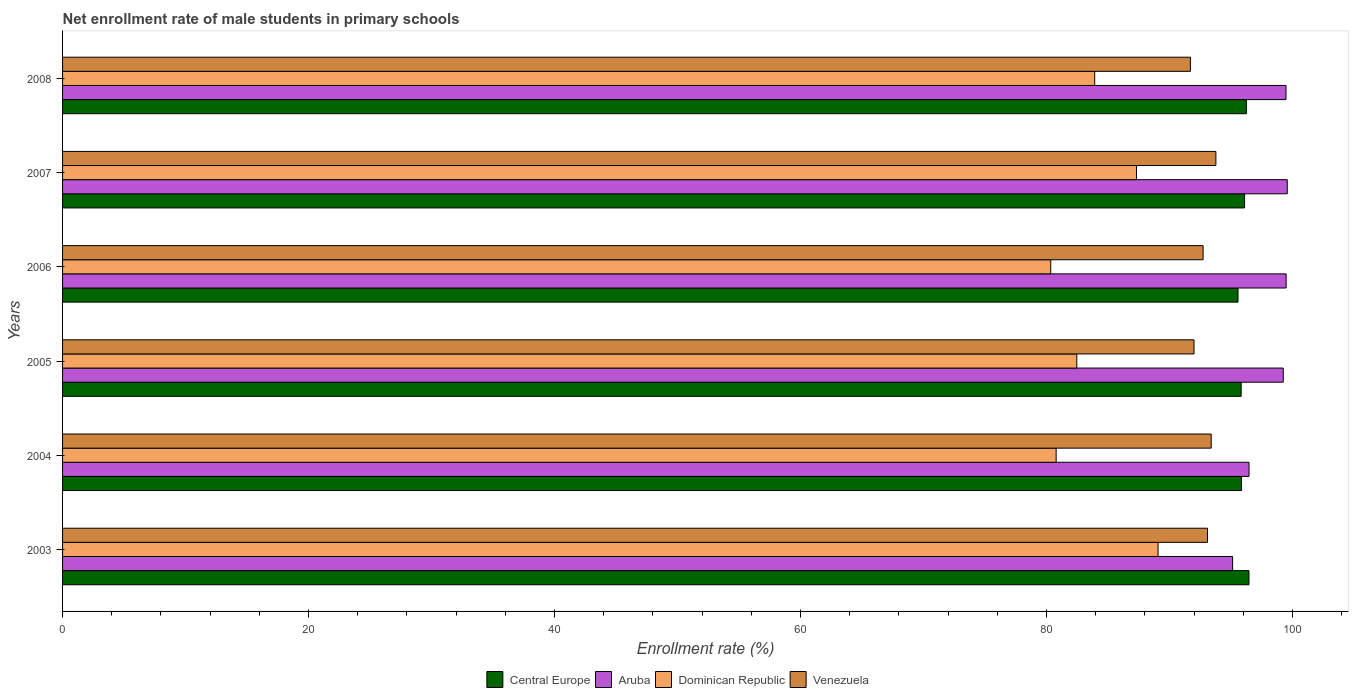How many groups of bars are there?
Your response must be concise. 6. How many bars are there on the 2nd tick from the bottom?
Keep it short and to the point. 4. What is the label of the 1st group of bars from the top?
Ensure brevity in your answer.  2008. What is the net enrollment rate of male students in primary schools in Dominican Republic in 2008?
Give a very brief answer. 83.91. Across all years, what is the maximum net enrollment rate of male students in primary schools in Venezuela?
Make the answer very short. 93.76. Across all years, what is the minimum net enrollment rate of male students in primary schools in Central Europe?
Offer a very short reply. 95.56. In which year was the net enrollment rate of male students in primary schools in Aruba maximum?
Your answer should be very brief. 2007. What is the total net enrollment rate of male students in primary schools in Dominican Republic in the graph?
Make the answer very short. 503.86. What is the difference between the net enrollment rate of male students in primary schools in Central Europe in 2004 and that in 2007?
Your answer should be very brief. -0.25. What is the difference between the net enrollment rate of male students in primary schools in Aruba in 2007 and the net enrollment rate of male students in primary schools in Venezuela in 2003?
Give a very brief answer. 6.48. What is the average net enrollment rate of male students in primary schools in Aruba per year?
Ensure brevity in your answer.  98.22. In the year 2004, what is the difference between the net enrollment rate of male students in primary schools in Central Europe and net enrollment rate of male students in primary schools in Venezuela?
Your answer should be very brief. 2.46. What is the ratio of the net enrollment rate of male students in primary schools in Venezuela in 2004 to that in 2007?
Keep it short and to the point. 1. Is the net enrollment rate of male students in primary schools in Venezuela in 2003 less than that in 2007?
Make the answer very short. Yes. What is the difference between the highest and the second highest net enrollment rate of male students in primary schools in Dominican Republic?
Provide a succinct answer. 1.75. What is the difference between the highest and the lowest net enrollment rate of male students in primary schools in Dominican Republic?
Offer a very short reply. 8.73. In how many years, is the net enrollment rate of male students in primary schools in Aruba greater than the average net enrollment rate of male students in primary schools in Aruba taken over all years?
Your answer should be compact. 4. Is the sum of the net enrollment rate of male students in primary schools in Aruba in 2006 and 2007 greater than the maximum net enrollment rate of male students in primary schools in Central Europe across all years?
Your answer should be compact. Yes. Is it the case that in every year, the sum of the net enrollment rate of male students in primary schools in Central Europe and net enrollment rate of male students in primary schools in Venezuela is greater than the sum of net enrollment rate of male students in primary schools in Dominican Republic and net enrollment rate of male students in primary schools in Aruba?
Your response must be concise. Yes. What does the 4th bar from the top in 2007 represents?
Make the answer very short. Central Europe. What does the 4th bar from the bottom in 2006 represents?
Provide a succinct answer. Venezuela. How many years are there in the graph?
Provide a succinct answer. 6. What is the difference between two consecutive major ticks on the X-axis?
Ensure brevity in your answer.  20. Are the values on the major ticks of X-axis written in scientific E-notation?
Your answer should be compact. No. Does the graph contain any zero values?
Provide a short and direct response. No. Does the graph contain grids?
Offer a very short reply. No. How many legend labels are there?
Your response must be concise. 4. What is the title of the graph?
Your answer should be very brief. Net enrollment rate of male students in primary schools. What is the label or title of the X-axis?
Provide a succinct answer. Enrollment rate (%). What is the Enrollment rate (%) in Central Europe in 2003?
Provide a succinct answer. 96.46. What is the Enrollment rate (%) of Aruba in 2003?
Provide a succinct answer. 95.13. What is the Enrollment rate (%) in Dominican Republic in 2003?
Provide a succinct answer. 89.06. What is the Enrollment rate (%) of Venezuela in 2003?
Make the answer very short. 93.08. What is the Enrollment rate (%) of Central Europe in 2004?
Provide a short and direct response. 95.85. What is the Enrollment rate (%) of Aruba in 2004?
Offer a very short reply. 96.46. What is the Enrollment rate (%) of Dominican Republic in 2004?
Give a very brief answer. 80.78. What is the Enrollment rate (%) in Venezuela in 2004?
Give a very brief answer. 93.38. What is the Enrollment rate (%) in Central Europe in 2005?
Provide a short and direct response. 95.82. What is the Enrollment rate (%) in Aruba in 2005?
Offer a very short reply. 99.24. What is the Enrollment rate (%) in Dominican Republic in 2005?
Offer a very short reply. 82.46. What is the Enrollment rate (%) in Venezuela in 2005?
Offer a very short reply. 91.99. What is the Enrollment rate (%) in Central Europe in 2006?
Your answer should be very brief. 95.56. What is the Enrollment rate (%) in Aruba in 2006?
Your answer should be very brief. 99.48. What is the Enrollment rate (%) in Dominican Republic in 2006?
Your response must be concise. 80.34. What is the Enrollment rate (%) of Venezuela in 2006?
Your answer should be very brief. 92.72. What is the Enrollment rate (%) in Central Europe in 2007?
Keep it short and to the point. 96.1. What is the Enrollment rate (%) of Aruba in 2007?
Give a very brief answer. 99.57. What is the Enrollment rate (%) in Dominican Republic in 2007?
Make the answer very short. 87.31. What is the Enrollment rate (%) of Venezuela in 2007?
Give a very brief answer. 93.76. What is the Enrollment rate (%) of Central Europe in 2008?
Ensure brevity in your answer.  96.24. What is the Enrollment rate (%) of Aruba in 2008?
Your response must be concise. 99.46. What is the Enrollment rate (%) in Dominican Republic in 2008?
Provide a short and direct response. 83.91. What is the Enrollment rate (%) in Venezuela in 2008?
Ensure brevity in your answer.  91.69. Across all years, what is the maximum Enrollment rate (%) of Central Europe?
Provide a short and direct response. 96.46. Across all years, what is the maximum Enrollment rate (%) in Aruba?
Your response must be concise. 99.57. Across all years, what is the maximum Enrollment rate (%) in Dominican Republic?
Your response must be concise. 89.06. Across all years, what is the maximum Enrollment rate (%) in Venezuela?
Keep it short and to the point. 93.76. Across all years, what is the minimum Enrollment rate (%) of Central Europe?
Provide a succinct answer. 95.56. Across all years, what is the minimum Enrollment rate (%) of Aruba?
Provide a succinct answer. 95.13. Across all years, what is the minimum Enrollment rate (%) of Dominican Republic?
Offer a very short reply. 80.34. Across all years, what is the minimum Enrollment rate (%) of Venezuela?
Your answer should be compact. 91.69. What is the total Enrollment rate (%) of Central Europe in the graph?
Ensure brevity in your answer.  576.03. What is the total Enrollment rate (%) in Aruba in the graph?
Give a very brief answer. 589.34. What is the total Enrollment rate (%) in Dominican Republic in the graph?
Provide a short and direct response. 503.86. What is the total Enrollment rate (%) of Venezuela in the graph?
Your answer should be compact. 556.64. What is the difference between the Enrollment rate (%) in Central Europe in 2003 and that in 2004?
Your answer should be very brief. 0.61. What is the difference between the Enrollment rate (%) in Aruba in 2003 and that in 2004?
Offer a very short reply. -1.34. What is the difference between the Enrollment rate (%) in Dominican Republic in 2003 and that in 2004?
Provide a succinct answer. 8.29. What is the difference between the Enrollment rate (%) in Venezuela in 2003 and that in 2004?
Ensure brevity in your answer.  -0.3. What is the difference between the Enrollment rate (%) of Central Europe in 2003 and that in 2005?
Keep it short and to the point. 0.63. What is the difference between the Enrollment rate (%) of Aruba in 2003 and that in 2005?
Keep it short and to the point. -4.12. What is the difference between the Enrollment rate (%) in Dominican Republic in 2003 and that in 2005?
Offer a terse response. 6.61. What is the difference between the Enrollment rate (%) of Venezuela in 2003 and that in 2005?
Your answer should be very brief. 1.1. What is the difference between the Enrollment rate (%) of Central Europe in 2003 and that in 2006?
Provide a short and direct response. 0.89. What is the difference between the Enrollment rate (%) of Aruba in 2003 and that in 2006?
Your answer should be compact. -4.35. What is the difference between the Enrollment rate (%) of Dominican Republic in 2003 and that in 2006?
Keep it short and to the point. 8.73. What is the difference between the Enrollment rate (%) of Venezuela in 2003 and that in 2006?
Keep it short and to the point. 0.36. What is the difference between the Enrollment rate (%) of Central Europe in 2003 and that in 2007?
Your answer should be compact. 0.36. What is the difference between the Enrollment rate (%) of Aruba in 2003 and that in 2007?
Your response must be concise. -4.44. What is the difference between the Enrollment rate (%) in Dominican Republic in 2003 and that in 2007?
Your answer should be very brief. 1.75. What is the difference between the Enrollment rate (%) in Venezuela in 2003 and that in 2007?
Offer a terse response. -0.68. What is the difference between the Enrollment rate (%) of Central Europe in 2003 and that in 2008?
Make the answer very short. 0.21. What is the difference between the Enrollment rate (%) of Aruba in 2003 and that in 2008?
Keep it short and to the point. -4.34. What is the difference between the Enrollment rate (%) in Dominican Republic in 2003 and that in 2008?
Keep it short and to the point. 5.15. What is the difference between the Enrollment rate (%) of Venezuela in 2003 and that in 2008?
Offer a terse response. 1.39. What is the difference between the Enrollment rate (%) of Central Europe in 2004 and that in 2005?
Give a very brief answer. 0.02. What is the difference between the Enrollment rate (%) in Aruba in 2004 and that in 2005?
Provide a succinct answer. -2.78. What is the difference between the Enrollment rate (%) in Dominican Republic in 2004 and that in 2005?
Make the answer very short. -1.68. What is the difference between the Enrollment rate (%) of Venezuela in 2004 and that in 2005?
Your answer should be compact. 1.4. What is the difference between the Enrollment rate (%) in Central Europe in 2004 and that in 2006?
Offer a terse response. 0.28. What is the difference between the Enrollment rate (%) of Aruba in 2004 and that in 2006?
Make the answer very short. -3.02. What is the difference between the Enrollment rate (%) in Dominican Republic in 2004 and that in 2006?
Make the answer very short. 0.44. What is the difference between the Enrollment rate (%) in Venezuela in 2004 and that in 2006?
Provide a short and direct response. 0.66. What is the difference between the Enrollment rate (%) of Central Europe in 2004 and that in 2007?
Your response must be concise. -0.25. What is the difference between the Enrollment rate (%) in Aruba in 2004 and that in 2007?
Your answer should be compact. -3.11. What is the difference between the Enrollment rate (%) of Dominican Republic in 2004 and that in 2007?
Make the answer very short. -6.53. What is the difference between the Enrollment rate (%) in Venezuela in 2004 and that in 2007?
Keep it short and to the point. -0.38. What is the difference between the Enrollment rate (%) in Central Europe in 2004 and that in 2008?
Provide a succinct answer. -0.4. What is the difference between the Enrollment rate (%) of Aruba in 2004 and that in 2008?
Give a very brief answer. -3. What is the difference between the Enrollment rate (%) in Dominican Republic in 2004 and that in 2008?
Make the answer very short. -3.13. What is the difference between the Enrollment rate (%) in Venezuela in 2004 and that in 2008?
Your answer should be compact. 1.69. What is the difference between the Enrollment rate (%) of Central Europe in 2005 and that in 2006?
Provide a short and direct response. 0.26. What is the difference between the Enrollment rate (%) in Aruba in 2005 and that in 2006?
Give a very brief answer. -0.24. What is the difference between the Enrollment rate (%) in Dominican Republic in 2005 and that in 2006?
Ensure brevity in your answer.  2.12. What is the difference between the Enrollment rate (%) of Venezuela in 2005 and that in 2006?
Make the answer very short. -0.74. What is the difference between the Enrollment rate (%) in Central Europe in 2005 and that in 2007?
Provide a short and direct response. -0.28. What is the difference between the Enrollment rate (%) in Aruba in 2005 and that in 2007?
Your response must be concise. -0.33. What is the difference between the Enrollment rate (%) in Dominican Republic in 2005 and that in 2007?
Give a very brief answer. -4.86. What is the difference between the Enrollment rate (%) in Venezuela in 2005 and that in 2007?
Make the answer very short. -1.78. What is the difference between the Enrollment rate (%) of Central Europe in 2005 and that in 2008?
Offer a very short reply. -0.42. What is the difference between the Enrollment rate (%) of Aruba in 2005 and that in 2008?
Make the answer very short. -0.22. What is the difference between the Enrollment rate (%) of Dominican Republic in 2005 and that in 2008?
Your response must be concise. -1.46. What is the difference between the Enrollment rate (%) of Venezuela in 2005 and that in 2008?
Your response must be concise. 0.29. What is the difference between the Enrollment rate (%) in Central Europe in 2006 and that in 2007?
Provide a succinct answer. -0.53. What is the difference between the Enrollment rate (%) in Aruba in 2006 and that in 2007?
Give a very brief answer. -0.09. What is the difference between the Enrollment rate (%) in Dominican Republic in 2006 and that in 2007?
Ensure brevity in your answer.  -6.97. What is the difference between the Enrollment rate (%) in Venezuela in 2006 and that in 2007?
Provide a succinct answer. -1.04. What is the difference between the Enrollment rate (%) of Central Europe in 2006 and that in 2008?
Your response must be concise. -0.68. What is the difference between the Enrollment rate (%) in Aruba in 2006 and that in 2008?
Make the answer very short. 0.01. What is the difference between the Enrollment rate (%) of Dominican Republic in 2006 and that in 2008?
Make the answer very short. -3.57. What is the difference between the Enrollment rate (%) of Venezuela in 2006 and that in 2008?
Provide a short and direct response. 1.03. What is the difference between the Enrollment rate (%) of Central Europe in 2007 and that in 2008?
Your answer should be compact. -0.14. What is the difference between the Enrollment rate (%) in Aruba in 2007 and that in 2008?
Provide a short and direct response. 0.1. What is the difference between the Enrollment rate (%) of Dominican Republic in 2007 and that in 2008?
Ensure brevity in your answer.  3.4. What is the difference between the Enrollment rate (%) in Venezuela in 2007 and that in 2008?
Offer a very short reply. 2.07. What is the difference between the Enrollment rate (%) of Central Europe in 2003 and the Enrollment rate (%) of Aruba in 2004?
Provide a short and direct response. -0. What is the difference between the Enrollment rate (%) of Central Europe in 2003 and the Enrollment rate (%) of Dominican Republic in 2004?
Provide a succinct answer. 15.68. What is the difference between the Enrollment rate (%) in Central Europe in 2003 and the Enrollment rate (%) in Venezuela in 2004?
Provide a short and direct response. 3.07. What is the difference between the Enrollment rate (%) of Aruba in 2003 and the Enrollment rate (%) of Dominican Republic in 2004?
Ensure brevity in your answer.  14.35. What is the difference between the Enrollment rate (%) in Aruba in 2003 and the Enrollment rate (%) in Venezuela in 2004?
Provide a succinct answer. 1.74. What is the difference between the Enrollment rate (%) of Dominican Republic in 2003 and the Enrollment rate (%) of Venezuela in 2004?
Make the answer very short. -4.32. What is the difference between the Enrollment rate (%) in Central Europe in 2003 and the Enrollment rate (%) in Aruba in 2005?
Keep it short and to the point. -2.78. What is the difference between the Enrollment rate (%) of Central Europe in 2003 and the Enrollment rate (%) of Dominican Republic in 2005?
Your answer should be very brief. 14. What is the difference between the Enrollment rate (%) in Central Europe in 2003 and the Enrollment rate (%) in Venezuela in 2005?
Provide a succinct answer. 4.47. What is the difference between the Enrollment rate (%) in Aruba in 2003 and the Enrollment rate (%) in Dominican Republic in 2005?
Provide a succinct answer. 12.67. What is the difference between the Enrollment rate (%) of Aruba in 2003 and the Enrollment rate (%) of Venezuela in 2005?
Give a very brief answer. 3.14. What is the difference between the Enrollment rate (%) of Dominican Republic in 2003 and the Enrollment rate (%) of Venezuela in 2005?
Offer a terse response. -2.92. What is the difference between the Enrollment rate (%) in Central Europe in 2003 and the Enrollment rate (%) in Aruba in 2006?
Your answer should be compact. -3.02. What is the difference between the Enrollment rate (%) of Central Europe in 2003 and the Enrollment rate (%) of Dominican Republic in 2006?
Your answer should be compact. 16.12. What is the difference between the Enrollment rate (%) in Central Europe in 2003 and the Enrollment rate (%) in Venezuela in 2006?
Provide a short and direct response. 3.73. What is the difference between the Enrollment rate (%) in Aruba in 2003 and the Enrollment rate (%) in Dominican Republic in 2006?
Make the answer very short. 14.79. What is the difference between the Enrollment rate (%) of Aruba in 2003 and the Enrollment rate (%) of Venezuela in 2006?
Ensure brevity in your answer.  2.4. What is the difference between the Enrollment rate (%) of Dominican Republic in 2003 and the Enrollment rate (%) of Venezuela in 2006?
Give a very brief answer. -3.66. What is the difference between the Enrollment rate (%) of Central Europe in 2003 and the Enrollment rate (%) of Aruba in 2007?
Offer a very short reply. -3.11. What is the difference between the Enrollment rate (%) in Central Europe in 2003 and the Enrollment rate (%) in Dominican Republic in 2007?
Provide a succinct answer. 9.14. What is the difference between the Enrollment rate (%) of Central Europe in 2003 and the Enrollment rate (%) of Venezuela in 2007?
Give a very brief answer. 2.69. What is the difference between the Enrollment rate (%) in Aruba in 2003 and the Enrollment rate (%) in Dominican Republic in 2007?
Give a very brief answer. 7.81. What is the difference between the Enrollment rate (%) in Aruba in 2003 and the Enrollment rate (%) in Venezuela in 2007?
Your answer should be compact. 1.36. What is the difference between the Enrollment rate (%) of Dominican Republic in 2003 and the Enrollment rate (%) of Venezuela in 2007?
Provide a short and direct response. -4.7. What is the difference between the Enrollment rate (%) in Central Europe in 2003 and the Enrollment rate (%) in Aruba in 2008?
Provide a succinct answer. -3.01. What is the difference between the Enrollment rate (%) in Central Europe in 2003 and the Enrollment rate (%) in Dominican Republic in 2008?
Provide a short and direct response. 12.54. What is the difference between the Enrollment rate (%) of Central Europe in 2003 and the Enrollment rate (%) of Venezuela in 2008?
Make the answer very short. 4.76. What is the difference between the Enrollment rate (%) in Aruba in 2003 and the Enrollment rate (%) in Dominican Republic in 2008?
Provide a short and direct response. 11.21. What is the difference between the Enrollment rate (%) in Aruba in 2003 and the Enrollment rate (%) in Venezuela in 2008?
Give a very brief answer. 3.43. What is the difference between the Enrollment rate (%) of Dominican Republic in 2003 and the Enrollment rate (%) of Venezuela in 2008?
Your answer should be very brief. -2.63. What is the difference between the Enrollment rate (%) of Central Europe in 2004 and the Enrollment rate (%) of Aruba in 2005?
Ensure brevity in your answer.  -3.39. What is the difference between the Enrollment rate (%) in Central Europe in 2004 and the Enrollment rate (%) in Dominican Republic in 2005?
Ensure brevity in your answer.  13.39. What is the difference between the Enrollment rate (%) in Central Europe in 2004 and the Enrollment rate (%) in Venezuela in 2005?
Make the answer very short. 3.86. What is the difference between the Enrollment rate (%) in Aruba in 2004 and the Enrollment rate (%) in Dominican Republic in 2005?
Provide a short and direct response. 14. What is the difference between the Enrollment rate (%) in Aruba in 2004 and the Enrollment rate (%) in Venezuela in 2005?
Provide a short and direct response. 4.47. What is the difference between the Enrollment rate (%) of Dominican Republic in 2004 and the Enrollment rate (%) of Venezuela in 2005?
Your answer should be very brief. -11.21. What is the difference between the Enrollment rate (%) of Central Europe in 2004 and the Enrollment rate (%) of Aruba in 2006?
Your response must be concise. -3.63. What is the difference between the Enrollment rate (%) in Central Europe in 2004 and the Enrollment rate (%) in Dominican Republic in 2006?
Your response must be concise. 15.51. What is the difference between the Enrollment rate (%) in Central Europe in 2004 and the Enrollment rate (%) in Venezuela in 2006?
Provide a short and direct response. 3.12. What is the difference between the Enrollment rate (%) in Aruba in 2004 and the Enrollment rate (%) in Dominican Republic in 2006?
Your answer should be very brief. 16.12. What is the difference between the Enrollment rate (%) of Aruba in 2004 and the Enrollment rate (%) of Venezuela in 2006?
Offer a very short reply. 3.74. What is the difference between the Enrollment rate (%) of Dominican Republic in 2004 and the Enrollment rate (%) of Venezuela in 2006?
Your answer should be compact. -11.95. What is the difference between the Enrollment rate (%) in Central Europe in 2004 and the Enrollment rate (%) in Aruba in 2007?
Your answer should be compact. -3.72. What is the difference between the Enrollment rate (%) in Central Europe in 2004 and the Enrollment rate (%) in Dominican Republic in 2007?
Provide a short and direct response. 8.53. What is the difference between the Enrollment rate (%) of Central Europe in 2004 and the Enrollment rate (%) of Venezuela in 2007?
Provide a short and direct response. 2.08. What is the difference between the Enrollment rate (%) in Aruba in 2004 and the Enrollment rate (%) in Dominican Republic in 2007?
Your response must be concise. 9.15. What is the difference between the Enrollment rate (%) in Aruba in 2004 and the Enrollment rate (%) in Venezuela in 2007?
Your answer should be very brief. 2.7. What is the difference between the Enrollment rate (%) of Dominican Republic in 2004 and the Enrollment rate (%) of Venezuela in 2007?
Your answer should be very brief. -12.99. What is the difference between the Enrollment rate (%) of Central Europe in 2004 and the Enrollment rate (%) of Aruba in 2008?
Your response must be concise. -3.62. What is the difference between the Enrollment rate (%) in Central Europe in 2004 and the Enrollment rate (%) in Dominican Republic in 2008?
Provide a short and direct response. 11.93. What is the difference between the Enrollment rate (%) of Central Europe in 2004 and the Enrollment rate (%) of Venezuela in 2008?
Ensure brevity in your answer.  4.15. What is the difference between the Enrollment rate (%) in Aruba in 2004 and the Enrollment rate (%) in Dominican Republic in 2008?
Keep it short and to the point. 12.55. What is the difference between the Enrollment rate (%) of Aruba in 2004 and the Enrollment rate (%) of Venezuela in 2008?
Give a very brief answer. 4.77. What is the difference between the Enrollment rate (%) of Dominican Republic in 2004 and the Enrollment rate (%) of Venezuela in 2008?
Make the answer very short. -10.92. What is the difference between the Enrollment rate (%) of Central Europe in 2005 and the Enrollment rate (%) of Aruba in 2006?
Offer a terse response. -3.66. What is the difference between the Enrollment rate (%) in Central Europe in 2005 and the Enrollment rate (%) in Dominican Republic in 2006?
Keep it short and to the point. 15.48. What is the difference between the Enrollment rate (%) of Central Europe in 2005 and the Enrollment rate (%) of Venezuela in 2006?
Provide a succinct answer. 3.1. What is the difference between the Enrollment rate (%) in Aruba in 2005 and the Enrollment rate (%) in Dominican Republic in 2006?
Offer a very short reply. 18.9. What is the difference between the Enrollment rate (%) in Aruba in 2005 and the Enrollment rate (%) in Venezuela in 2006?
Ensure brevity in your answer.  6.52. What is the difference between the Enrollment rate (%) in Dominican Republic in 2005 and the Enrollment rate (%) in Venezuela in 2006?
Your answer should be compact. -10.27. What is the difference between the Enrollment rate (%) in Central Europe in 2005 and the Enrollment rate (%) in Aruba in 2007?
Keep it short and to the point. -3.75. What is the difference between the Enrollment rate (%) of Central Europe in 2005 and the Enrollment rate (%) of Dominican Republic in 2007?
Give a very brief answer. 8.51. What is the difference between the Enrollment rate (%) in Central Europe in 2005 and the Enrollment rate (%) in Venezuela in 2007?
Make the answer very short. 2.06. What is the difference between the Enrollment rate (%) in Aruba in 2005 and the Enrollment rate (%) in Dominican Republic in 2007?
Provide a short and direct response. 11.93. What is the difference between the Enrollment rate (%) of Aruba in 2005 and the Enrollment rate (%) of Venezuela in 2007?
Your answer should be compact. 5.48. What is the difference between the Enrollment rate (%) of Dominican Republic in 2005 and the Enrollment rate (%) of Venezuela in 2007?
Keep it short and to the point. -11.31. What is the difference between the Enrollment rate (%) in Central Europe in 2005 and the Enrollment rate (%) in Aruba in 2008?
Offer a terse response. -3.64. What is the difference between the Enrollment rate (%) in Central Europe in 2005 and the Enrollment rate (%) in Dominican Republic in 2008?
Provide a succinct answer. 11.91. What is the difference between the Enrollment rate (%) in Central Europe in 2005 and the Enrollment rate (%) in Venezuela in 2008?
Make the answer very short. 4.13. What is the difference between the Enrollment rate (%) of Aruba in 2005 and the Enrollment rate (%) of Dominican Republic in 2008?
Your answer should be compact. 15.33. What is the difference between the Enrollment rate (%) of Aruba in 2005 and the Enrollment rate (%) of Venezuela in 2008?
Offer a terse response. 7.55. What is the difference between the Enrollment rate (%) in Dominican Republic in 2005 and the Enrollment rate (%) in Venezuela in 2008?
Your response must be concise. -9.24. What is the difference between the Enrollment rate (%) in Central Europe in 2006 and the Enrollment rate (%) in Aruba in 2007?
Provide a succinct answer. -4. What is the difference between the Enrollment rate (%) in Central Europe in 2006 and the Enrollment rate (%) in Dominican Republic in 2007?
Provide a short and direct response. 8.25. What is the difference between the Enrollment rate (%) of Central Europe in 2006 and the Enrollment rate (%) of Venezuela in 2007?
Provide a succinct answer. 1.8. What is the difference between the Enrollment rate (%) of Aruba in 2006 and the Enrollment rate (%) of Dominican Republic in 2007?
Provide a short and direct response. 12.17. What is the difference between the Enrollment rate (%) of Aruba in 2006 and the Enrollment rate (%) of Venezuela in 2007?
Give a very brief answer. 5.71. What is the difference between the Enrollment rate (%) of Dominican Republic in 2006 and the Enrollment rate (%) of Venezuela in 2007?
Keep it short and to the point. -13.43. What is the difference between the Enrollment rate (%) in Central Europe in 2006 and the Enrollment rate (%) in Aruba in 2008?
Provide a short and direct response. -3.9. What is the difference between the Enrollment rate (%) in Central Europe in 2006 and the Enrollment rate (%) in Dominican Republic in 2008?
Give a very brief answer. 11.65. What is the difference between the Enrollment rate (%) in Central Europe in 2006 and the Enrollment rate (%) in Venezuela in 2008?
Offer a terse response. 3.87. What is the difference between the Enrollment rate (%) of Aruba in 2006 and the Enrollment rate (%) of Dominican Republic in 2008?
Make the answer very short. 15.56. What is the difference between the Enrollment rate (%) in Aruba in 2006 and the Enrollment rate (%) in Venezuela in 2008?
Your answer should be very brief. 7.78. What is the difference between the Enrollment rate (%) of Dominican Republic in 2006 and the Enrollment rate (%) of Venezuela in 2008?
Offer a very short reply. -11.35. What is the difference between the Enrollment rate (%) in Central Europe in 2007 and the Enrollment rate (%) in Aruba in 2008?
Give a very brief answer. -3.37. What is the difference between the Enrollment rate (%) in Central Europe in 2007 and the Enrollment rate (%) in Dominican Republic in 2008?
Give a very brief answer. 12.19. What is the difference between the Enrollment rate (%) of Central Europe in 2007 and the Enrollment rate (%) of Venezuela in 2008?
Keep it short and to the point. 4.4. What is the difference between the Enrollment rate (%) in Aruba in 2007 and the Enrollment rate (%) in Dominican Republic in 2008?
Make the answer very short. 15.66. What is the difference between the Enrollment rate (%) of Aruba in 2007 and the Enrollment rate (%) of Venezuela in 2008?
Make the answer very short. 7.87. What is the difference between the Enrollment rate (%) of Dominican Republic in 2007 and the Enrollment rate (%) of Venezuela in 2008?
Ensure brevity in your answer.  -4.38. What is the average Enrollment rate (%) in Central Europe per year?
Your answer should be compact. 96. What is the average Enrollment rate (%) of Aruba per year?
Provide a succinct answer. 98.22. What is the average Enrollment rate (%) in Dominican Republic per year?
Your answer should be very brief. 83.98. What is the average Enrollment rate (%) in Venezuela per year?
Your response must be concise. 92.77. In the year 2003, what is the difference between the Enrollment rate (%) in Central Europe and Enrollment rate (%) in Aruba?
Your answer should be compact. 1.33. In the year 2003, what is the difference between the Enrollment rate (%) in Central Europe and Enrollment rate (%) in Dominican Republic?
Your response must be concise. 7.39. In the year 2003, what is the difference between the Enrollment rate (%) of Central Europe and Enrollment rate (%) of Venezuela?
Your response must be concise. 3.37. In the year 2003, what is the difference between the Enrollment rate (%) of Aruba and Enrollment rate (%) of Dominican Republic?
Your response must be concise. 6.06. In the year 2003, what is the difference between the Enrollment rate (%) of Aruba and Enrollment rate (%) of Venezuela?
Keep it short and to the point. 2.04. In the year 2003, what is the difference between the Enrollment rate (%) of Dominican Republic and Enrollment rate (%) of Venezuela?
Make the answer very short. -4.02. In the year 2004, what is the difference between the Enrollment rate (%) in Central Europe and Enrollment rate (%) in Aruba?
Your answer should be very brief. -0.61. In the year 2004, what is the difference between the Enrollment rate (%) in Central Europe and Enrollment rate (%) in Dominican Republic?
Give a very brief answer. 15.07. In the year 2004, what is the difference between the Enrollment rate (%) in Central Europe and Enrollment rate (%) in Venezuela?
Provide a succinct answer. 2.46. In the year 2004, what is the difference between the Enrollment rate (%) in Aruba and Enrollment rate (%) in Dominican Republic?
Give a very brief answer. 15.68. In the year 2004, what is the difference between the Enrollment rate (%) of Aruba and Enrollment rate (%) of Venezuela?
Ensure brevity in your answer.  3.08. In the year 2004, what is the difference between the Enrollment rate (%) in Dominican Republic and Enrollment rate (%) in Venezuela?
Give a very brief answer. -12.61. In the year 2005, what is the difference between the Enrollment rate (%) of Central Europe and Enrollment rate (%) of Aruba?
Offer a terse response. -3.42. In the year 2005, what is the difference between the Enrollment rate (%) in Central Europe and Enrollment rate (%) in Dominican Republic?
Ensure brevity in your answer.  13.36. In the year 2005, what is the difference between the Enrollment rate (%) in Central Europe and Enrollment rate (%) in Venezuela?
Keep it short and to the point. 3.83. In the year 2005, what is the difference between the Enrollment rate (%) in Aruba and Enrollment rate (%) in Dominican Republic?
Provide a succinct answer. 16.78. In the year 2005, what is the difference between the Enrollment rate (%) in Aruba and Enrollment rate (%) in Venezuela?
Make the answer very short. 7.25. In the year 2005, what is the difference between the Enrollment rate (%) in Dominican Republic and Enrollment rate (%) in Venezuela?
Your response must be concise. -9.53. In the year 2006, what is the difference between the Enrollment rate (%) in Central Europe and Enrollment rate (%) in Aruba?
Offer a terse response. -3.91. In the year 2006, what is the difference between the Enrollment rate (%) of Central Europe and Enrollment rate (%) of Dominican Republic?
Provide a short and direct response. 15.23. In the year 2006, what is the difference between the Enrollment rate (%) in Central Europe and Enrollment rate (%) in Venezuela?
Give a very brief answer. 2.84. In the year 2006, what is the difference between the Enrollment rate (%) of Aruba and Enrollment rate (%) of Dominican Republic?
Provide a short and direct response. 19.14. In the year 2006, what is the difference between the Enrollment rate (%) in Aruba and Enrollment rate (%) in Venezuela?
Keep it short and to the point. 6.75. In the year 2006, what is the difference between the Enrollment rate (%) of Dominican Republic and Enrollment rate (%) of Venezuela?
Provide a short and direct response. -12.39. In the year 2007, what is the difference between the Enrollment rate (%) of Central Europe and Enrollment rate (%) of Aruba?
Keep it short and to the point. -3.47. In the year 2007, what is the difference between the Enrollment rate (%) of Central Europe and Enrollment rate (%) of Dominican Republic?
Provide a succinct answer. 8.79. In the year 2007, what is the difference between the Enrollment rate (%) of Central Europe and Enrollment rate (%) of Venezuela?
Offer a very short reply. 2.33. In the year 2007, what is the difference between the Enrollment rate (%) in Aruba and Enrollment rate (%) in Dominican Republic?
Make the answer very short. 12.26. In the year 2007, what is the difference between the Enrollment rate (%) in Aruba and Enrollment rate (%) in Venezuela?
Provide a succinct answer. 5.8. In the year 2007, what is the difference between the Enrollment rate (%) in Dominican Republic and Enrollment rate (%) in Venezuela?
Your answer should be compact. -6.45. In the year 2008, what is the difference between the Enrollment rate (%) of Central Europe and Enrollment rate (%) of Aruba?
Offer a terse response. -3.22. In the year 2008, what is the difference between the Enrollment rate (%) in Central Europe and Enrollment rate (%) in Dominican Republic?
Offer a very short reply. 12.33. In the year 2008, what is the difference between the Enrollment rate (%) in Central Europe and Enrollment rate (%) in Venezuela?
Your answer should be very brief. 4.55. In the year 2008, what is the difference between the Enrollment rate (%) in Aruba and Enrollment rate (%) in Dominican Republic?
Keep it short and to the point. 15.55. In the year 2008, what is the difference between the Enrollment rate (%) of Aruba and Enrollment rate (%) of Venezuela?
Ensure brevity in your answer.  7.77. In the year 2008, what is the difference between the Enrollment rate (%) in Dominican Republic and Enrollment rate (%) in Venezuela?
Your response must be concise. -7.78. What is the ratio of the Enrollment rate (%) of Central Europe in 2003 to that in 2004?
Provide a succinct answer. 1.01. What is the ratio of the Enrollment rate (%) of Aruba in 2003 to that in 2004?
Your response must be concise. 0.99. What is the ratio of the Enrollment rate (%) in Dominican Republic in 2003 to that in 2004?
Provide a short and direct response. 1.1. What is the ratio of the Enrollment rate (%) in Central Europe in 2003 to that in 2005?
Make the answer very short. 1.01. What is the ratio of the Enrollment rate (%) in Aruba in 2003 to that in 2005?
Keep it short and to the point. 0.96. What is the ratio of the Enrollment rate (%) of Dominican Republic in 2003 to that in 2005?
Keep it short and to the point. 1.08. What is the ratio of the Enrollment rate (%) in Venezuela in 2003 to that in 2005?
Offer a terse response. 1.01. What is the ratio of the Enrollment rate (%) of Central Europe in 2003 to that in 2006?
Offer a very short reply. 1.01. What is the ratio of the Enrollment rate (%) of Aruba in 2003 to that in 2006?
Provide a short and direct response. 0.96. What is the ratio of the Enrollment rate (%) of Dominican Republic in 2003 to that in 2006?
Make the answer very short. 1.11. What is the ratio of the Enrollment rate (%) of Venezuela in 2003 to that in 2006?
Your response must be concise. 1. What is the ratio of the Enrollment rate (%) in Central Europe in 2003 to that in 2007?
Provide a succinct answer. 1. What is the ratio of the Enrollment rate (%) in Aruba in 2003 to that in 2007?
Make the answer very short. 0.96. What is the ratio of the Enrollment rate (%) of Dominican Republic in 2003 to that in 2007?
Your response must be concise. 1.02. What is the ratio of the Enrollment rate (%) of Venezuela in 2003 to that in 2007?
Give a very brief answer. 0.99. What is the ratio of the Enrollment rate (%) of Aruba in 2003 to that in 2008?
Ensure brevity in your answer.  0.96. What is the ratio of the Enrollment rate (%) in Dominican Republic in 2003 to that in 2008?
Make the answer very short. 1.06. What is the ratio of the Enrollment rate (%) in Venezuela in 2003 to that in 2008?
Give a very brief answer. 1.02. What is the ratio of the Enrollment rate (%) in Central Europe in 2004 to that in 2005?
Your answer should be compact. 1. What is the ratio of the Enrollment rate (%) in Dominican Republic in 2004 to that in 2005?
Provide a short and direct response. 0.98. What is the ratio of the Enrollment rate (%) of Venezuela in 2004 to that in 2005?
Keep it short and to the point. 1.02. What is the ratio of the Enrollment rate (%) in Aruba in 2004 to that in 2006?
Ensure brevity in your answer.  0.97. What is the ratio of the Enrollment rate (%) of Venezuela in 2004 to that in 2006?
Make the answer very short. 1.01. What is the ratio of the Enrollment rate (%) in Aruba in 2004 to that in 2007?
Make the answer very short. 0.97. What is the ratio of the Enrollment rate (%) in Dominican Republic in 2004 to that in 2007?
Provide a succinct answer. 0.93. What is the ratio of the Enrollment rate (%) of Venezuela in 2004 to that in 2007?
Your answer should be very brief. 1. What is the ratio of the Enrollment rate (%) in Aruba in 2004 to that in 2008?
Offer a very short reply. 0.97. What is the ratio of the Enrollment rate (%) of Dominican Republic in 2004 to that in 2008?
Your response must be concise. 0.96. What is the ratio of the Enrollment rate (%) of Venezuela in 2004 to that in 2008?
Your answer should be very brief. 1.02. What is the ratio of the Enrollment rate (%) of Central Europe in 2005 to that in 2006?
Your response must be concise. 1. What is the ratio of the Enrollment rate (%) of Aruba in 2005 to that in 2006?
Offer a terse response. 1. What is the ratio of the Enrollment rate (%) of Dominican Republic in 2005 to that in 2006?
Provide a succinct answer. 1.03. What is the ratio of the Enrollment rate (%) in Venezuela in 2005 to that in 2006?
Your answer should be very brief. 0.99. What is the ratio of the Enrollment rate (%) in Aruba in 2005 to that in 2007?
Your response must be concise. 1. What is the ratio of the Enrollment rate (%) in Aruba in 2005 to that in 2008?
Provide a succinct answer. 1. What is the ratio of the Enrollment rate (%) of Dominican Republic in 2005 to that in 2008?
Ensure brevity in your answer.  0.98. What is the ratio of the Enrollment rate (%) in Venezuela in 2005 to that in 2008?
Provide a succinct answer. 1. What is the ratio of the Enrollment rate (%) of Dominican Republic in 2006 to that in 2007?
Make the answer very short. 0.92. What is the ratio of the Enrollment rate (%) in Venezuela in 2006 to that in 2007?
Offer a terse response. 0.99. What is the ratio of the Enrollment rate (%) of Central Europe in 2006 to that in 2008?
Give a very brief answer. 0.99. What is the ratio of the Enrollment rate (%) in Dominican Republic in 2006 to that in 2008?
Your response must be concise. 0.96. What is the ratio of the Enrollment rate (%) in Venezuela in 2006 to that in 2008?
Provide a succinct answer. 1.01. What is the ratio of the Enrollment rate (%) in Central Europe in 2007 to that in 2008?
Provide a short and direct response. 1. What is the ratio of the Enrollment rate (%) in Dominican Republic in 2007 to that in 2008?
Give a very brief answer. 1.04. What is the ratio of the Enrollment rate (%) of Venezuela in 2007 to that in 2008?
Keep it short and to the point. 1.02. What is the difference between the highest and the second highest Enrollment rate (%) of Central Europe?
Ensure brevity in your answer.  0.21. What is the difference between the highest and the second highest Enrollment rate (%) in Aruba?
Make the answer very short. 0.09. What is the difference between the highest and the second highest Enrollment rate (%) of Dominican Republic?
Your response must be concise. 1.75. What is the difference between the highest and the second highest Enrollment rate (%) of Venezuela?
Your answer should be very brief. 0.38. What is the difference between the highest and the lowest Enrollment rate (%) in Central Europe?
Your answer should be very brief. 0.89. What is the difference between the highest and the lowest Enrollment rate (%) in Aruba?
Offer a very short reply. 4.44. What is the difference between the highest and the lowest Enrollment rate (%) in Dominican Republic?
Offer a very short reply. 8.73. What is the difference between the highest and the lowest Enrollment rate (%) in Venezuela?
Provide a short and direct response. 2.07. 